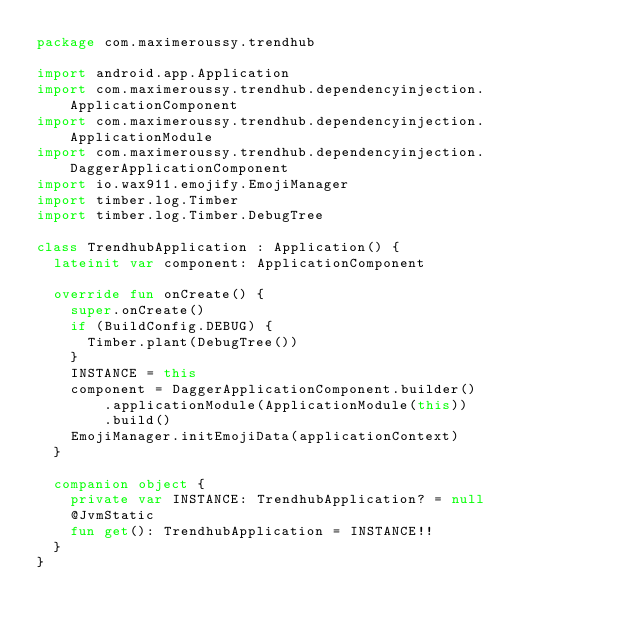Convert code to text. <code><loc_0><loc_0><loc_500><loc_500><_Kotlin_>package com.maximeroussy.trendhub

import android.app.Application
import com.maximeroussy.trendhub.dependencyinjection.ApplicationComponent
import com.maximeroussy.trendhub.dependencyinjection.ApplicationModule
import com.maximeroussy.trendhub.dependencyinjection.DaggerApplicationComponent
import io.wax911.emojify.EmojiManager
import timber.log.Timber
import timber.log.Timber.DebugTree

class TrendhubApplication : Application() {
  lateinit var component: ApplicationComponent

  override fun onCreate() {
    super.onCreate()
    if (BuildConfig.DEBUG) {
      Timber.plant(DebugTree())
    }
    INSTANCE = this
    component = DaggerApplicationComponent.builder()
        .applicationModule(ApplicationModule(this))
        .build()
    EmojiManager.initEmojiData(applicationContext)
  }

  companion object {
    private var INSTANCE: TrendhubApplication? = null
    @JvmStatic
    fun get(): TrendhubApplication = INSTANCE!!
  }
}
</code> 